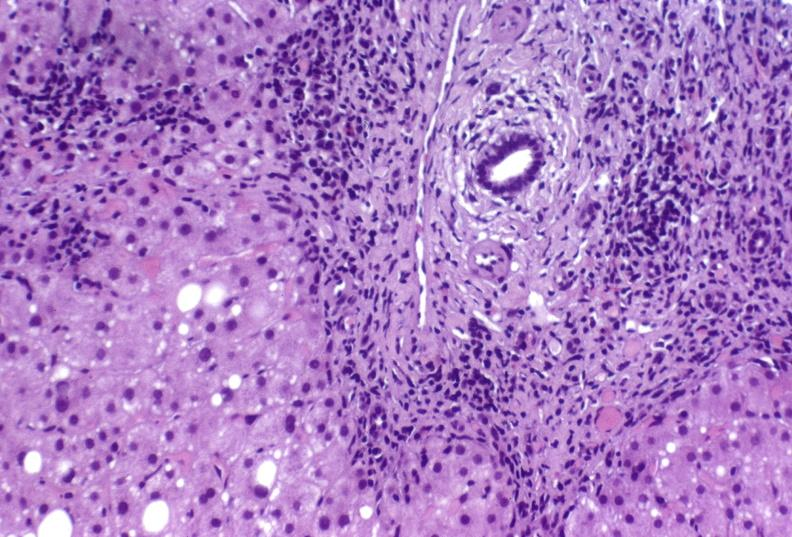does this image show hepatitis c virus?
Answer the question using a single word or phrase. Yes 